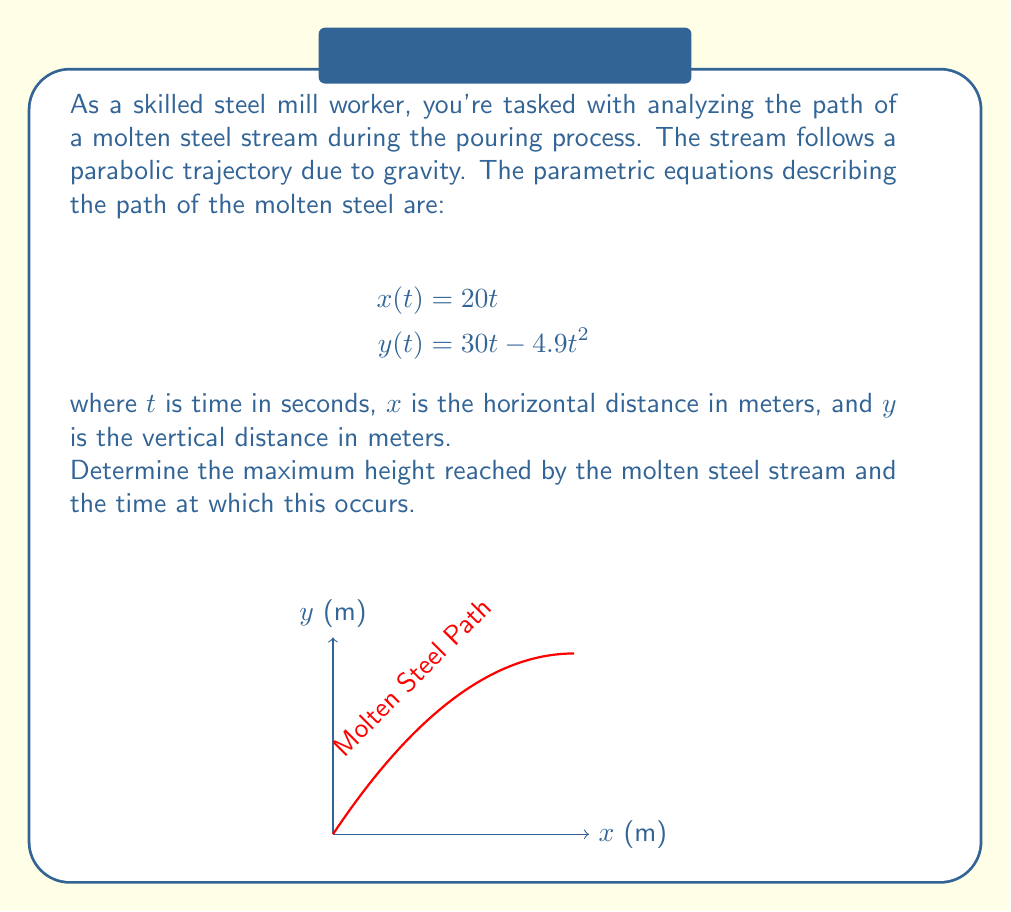What is the answer to this math problem? Let's approach this step-by-step:

1) The maximum height occurs when the vertical velocity is zero. We can find this by taking the derivative of $y(t)$ with respect to $t$ and setting it to zero.

2) $\frac{dy}{dt} = 30 - 9.8t$

3) Set this equal to zero:
   $30 - 9.8t = 0$

4) Solve for $t$:
   $9.8t = 30$
   $t = \frac{30}{9.8} = 3.0612$ seconds

5) This is the time at which the maximum height occurs. To find the maximum height, we plug this value of $t$ back into the equation for $y(t)$:

   $y(3.0612) = 30(3.0612) - 4.9(3.0612)^2$

6) Calculating this:
   $y(3.0612) = 91.836 - 45.918 = 45.918$ meters

Therefore, the maximum height is approximately 45.92 meters, occurring at about 3.06 seconds after the pour begins.
Answer: Maximum height: 45.92 m at t = 3.06 s 